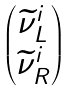<formula> <loc_0><loc_0><loc_500><loc_500>\begin{pmatrix} \widetilde { \nu } _ { L } ^ { i } \\ \widetilde { \nu } _ { R } ^ { i } \end{pmatrix}</formula> 